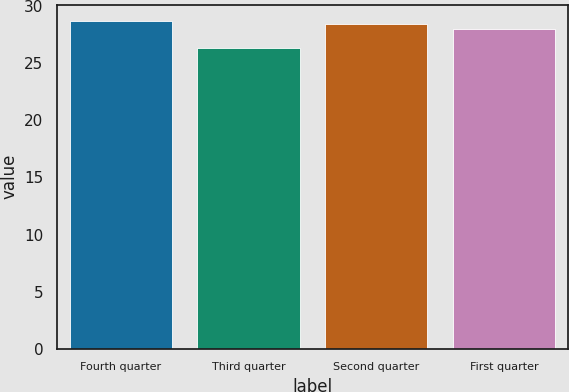<chart> <loc_0><loc_0><loc_500><loc_500><bar_chart><fcel>Fourth quarter<fcel>Third quarter<fcel>Second quarter<fcel>First quarter<nl><fcel>28.71<fcel>26.31<fcel>28.48<fcel>28<nl></chart> 